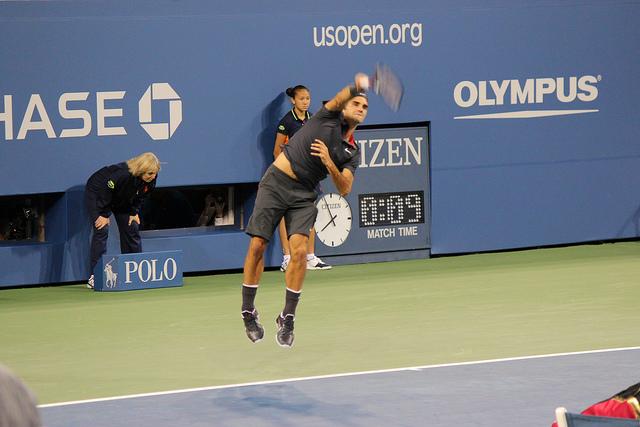What clothing company is sponsoring?
Give a very brief answer. Polo. What bank is this event sponsored by?
Write a very short answer. Chase. What sport is being played?
Write a very short answer. Tennis. 